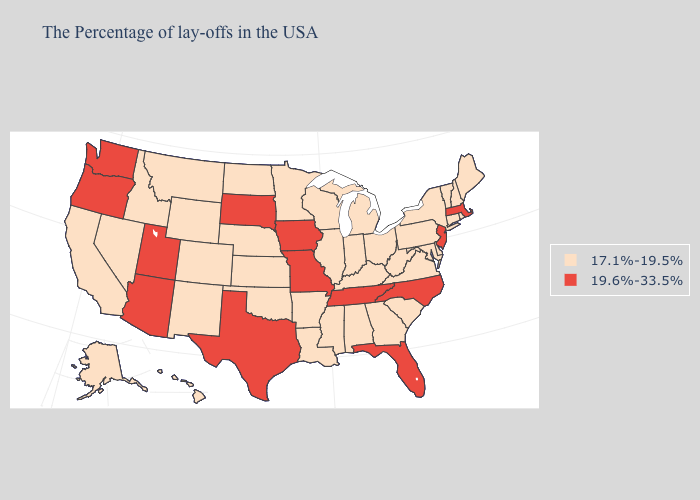Does Illinois have the highest value in the MidWest?
Short answer required. No. Name the states that have a value in the range 19.6%-33.5%?
Be succinct. Massachusetts, New Jersey, North Carolina, Florida, Tennessee, Missouri, Iowa, Texas, South Dakota, Utah, Arizona, Washington, Oregon. What is the lowest value in the USA?
Keep it brief. 17.1%-19.5%. Which states have the lowest value in the West?
Answer briefly. Wyoming, Colorado, New Mexico, Montana, Idaho, Nevada, California, Alaska, Hawaii. Does the map have missing data?
Keep it brief. No. Which states have the highest value in the USA?
Give a very brief answer. Massachusetts, New Jersey, North Carolina, Florida, Tennessee, Missouri, Iowa, Texas, South Dakota, Utah, Arizona, Washington, Oregon. What is the lowest value in the USA?
Concise answer only. 17.1%-19.5%. What is the highest value in the South ?
Write a very short answer. 19.6%-33.5%. Name the states that have a value in the range 19.6%-33.5%?
Answer briefly. Massachusetts, New Jersey, North Carolina, Florida, Tennessee, Missouri, Iowa, Texas, South Dakota, Utah, Arizona, Washington, Oregon. Name the states that have a value in the range 19.6%-33.5%?
Concise answer only. Massachusetts, New Jersey, North Carolina, Florida, Tennessee, Missouri, Iowa, Texas, South Dakota, Utah, Arizona, Washington, Oregon. What is the value of Georgia?
Write a very short answer. 17.1%-19.5%. What is the value of Oklahoma?
Be succinct. 17.1%-19.5%. Does the first symbol in the legend represent the smallest category?
Answer briefly. Yes. What is the lowest value in the South?
Be succinct. 17.1%-19.5%. Name the states that have a value in the range 19.6%-33.5%?
Answer briefly. Massachusetts, New Jersey, North Carolina, Florida, Tennessee, Missouri, Iowa, Texas, South Dakota, Utah, Arizona, Washington, Oregon. 